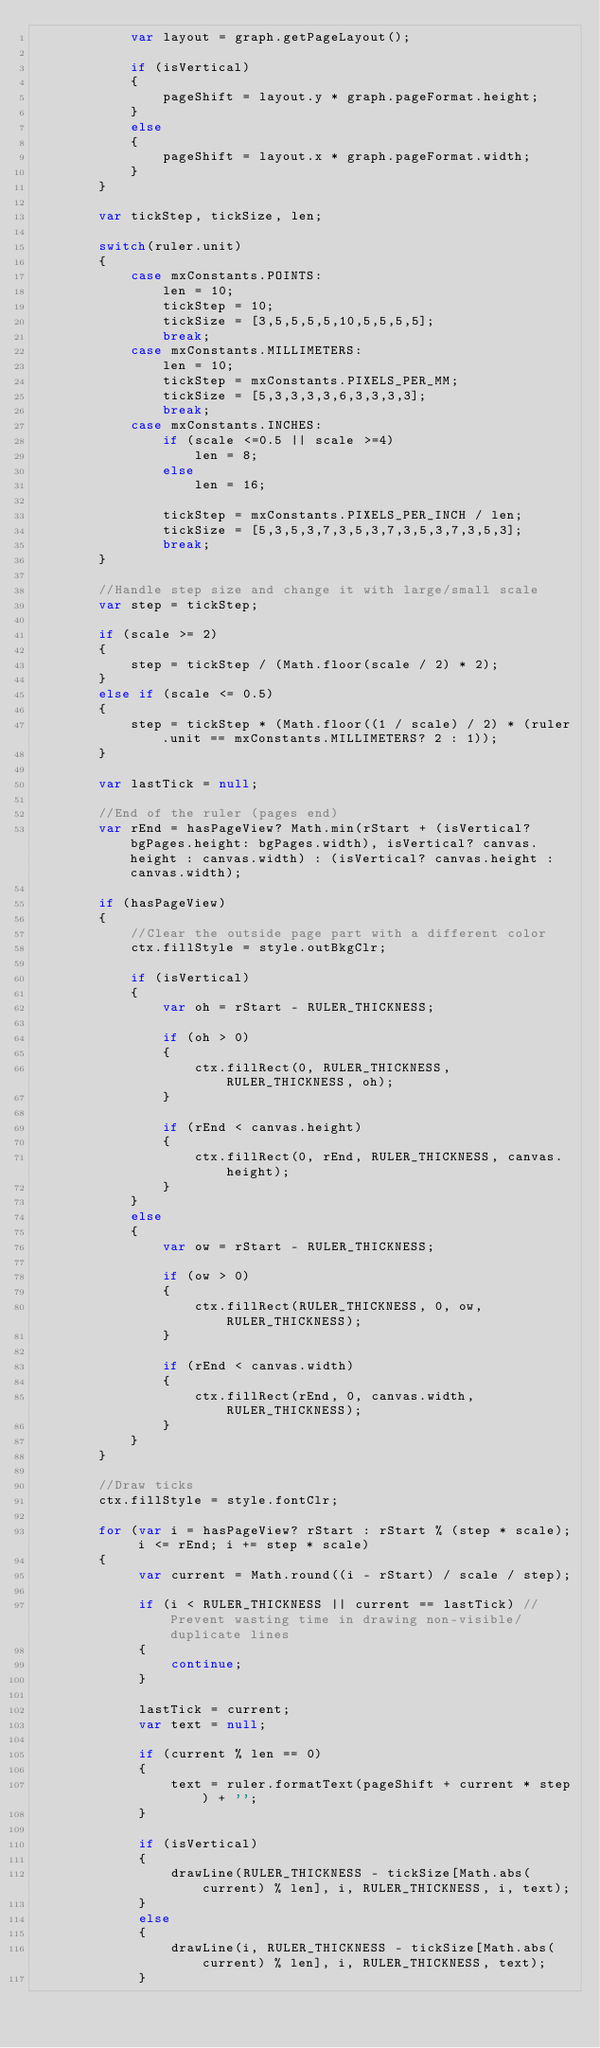<code> <loc_0><loc_0><loc_500><loc_500><_JavaScript_>			var layout = graph.getPageLayout();
	
	        if (isVertical) 
	        {
	            pageShift = layout.y * graph.pageFormat.height;
	        }
	        else
	        {
	            pageShift = layout.x * graph.pageFormat.width;
	        }
        }
        
        var tickStep, tickSize, len;

        switch(ruler.unit) 
        {
            case mxConstants.POINTS:
                len = 10;
                tickStep = 10;
                tickSize = [3,5,5,5,5,10,5,5,5,5];
                break;
            case mxConstants.MILLIMETERS:
                len = 10;
                tickStep = mxConstants.PIXELS_PER_MM;
                tickSize = [5,3,3,3,3,6,3,3,3,3];
                break;
            case mxConstants.INCHES:
            	if (scale <=0.5 || scale >=4)
                    len = 8;
                else
                    len = 16;
                
                tickStep = mxConstants.PIXELS_PER_INCH / len;
                tickSize = [5,3,5,3,7,3,5,3,7,3,5,3,7,3,5,3];
                break;
        }

        //Handle step size and change it with large/small scale
        var step = tickStep;
        
        if (scale >= 2)
    	{
        	step = tickStep / (Math.floor(scale / 2) * 2);
    	}
        else if (scale <= 0.5)
    	{
        	step = tickStep * (Math.floor((1 / scale) / 2) * (ruler.unit == mxConstants.MILLIMETERS? 2 : 1));
    	}

        var lastTick = null;
        
        //End of the ruler (pages end)
        var rEnd = hasPageView? Math.min(rStart + (isVertical? bgPages.height: bgPages.width), isVertical? canvas.height : canvas.width) : (isVertical? canvas.height : canvas.width);

        if (hasPageView)
        {
	        //Clear the outside page part with a different color
	        ctx.fillStyle = style.outBkgClr;
	        
	        if (isVertical)
	    	{
				var oh = rStart - RULER_THICKNESS;
				
				if (oh > 0)
				{
					ctx.fillRect(0, RULER_THICKNESS, RULER_THICKNESS, oh);
				}

				if (rEnd < canvas.height)
				{
					ctx.fillRect(0, rEnd, RULER_THICKNESS, canvas.height);
				}
	    	}
	        else
	        {
				var ow = rStart - RULER_THICKNESS;
		        
				if (ow > 0)
				{
					ctx.fillRect(RULER_THICKNESS, 0, ow, RULER_THICKNESS);	
				}
		        
				if (rEnd < canvas.width)
				{
					ctx.fillRect(rEnd, 0, canvas.width, RULER_THICKNESS);
				}
	        }
        }
        
        //Draw ticks
        ctx.fillStyle = style.fontClr;
        
        for (var i = hasPageView? rStart : rStart % (step * scale); i <= rEnd; i += step * scale) 
        {
        	 var current = Math.round((i - rStart) / scale / step);
        	
        	 if (i < RULER_THICKNESS || current == lastTick) //Prevent wasting time in drawing non-visible/duplicate lines
         	 {
             	 continue;
         	 }
             
             lastTick = current;
             var text = null;
             
             if (current % len == 0) 
             {
                 text = ruler.formatText(pageShift + current * step) + '';
             }
        		 
        	 if (isVertical) 
             {
                 drawLine(RULER_THICKNESS - tickSize[Math.abs(current) % len], i, RULER_THICKNESS, i, text);
             }
             else
             {
                 drawLine(i, RULER_THICKNESS - tickSize[Math.abs(current) % len], i, RULER_THICKNESS, text);
             }</code> 